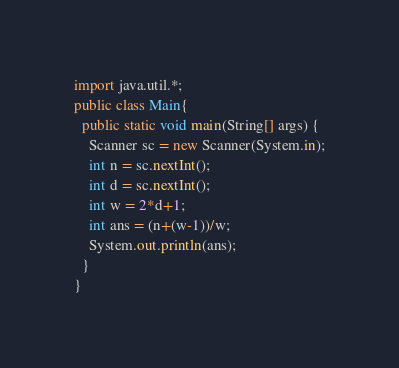Convert code to text. <code><loc_0><loc_0><loc_500><loc_500><_Java_>import java.util.*;
public class Main{
  public static void main(String[] args) {
    Scanner sc = new Scanner(System.in);
    int n = sc.nextInt();
    int d = sc.nextInt();
    int w = 2*d+1;
    int ans = (n+(w-1))/w;
    System.out.println(ans);
  }
}
</code> 